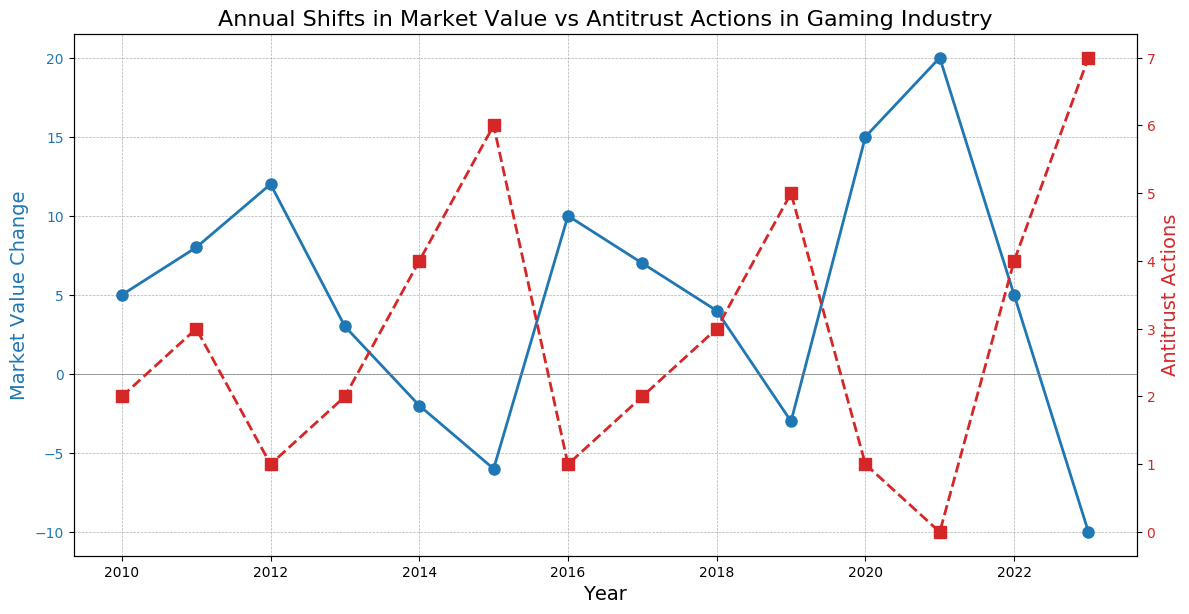How many years had a negative shift in market value? From the figure, identify the years where the line for market value change falls below the zero horizontal line. There are 4 data points where the market value change is negative.
Answer: 4 In which year did the market value change peak? Look for the highest point on the blue line representing the market value change. The peak value is 20 in the year 2021.
Answer: 2021 Which year had the highest number of antitrust actions and what was the market value change in that year? Find the peak of the red line which shows the number of antitrust actions. In 2023, there were 7 antitrust actions and the market value change was -10.
Answer: 2023, -10 What was the average market value change from 2010 to 2013? Sum the market value changes from 2010, 2011, 2012, and 2013, then divide by 4. (5 + 8 + 12 + 3) / 4 = 7
Answer: 7 Compare the market value changes in 2015 and 2016. Which was greater? Compare the data points on the blue line for 2015 and 2016. In 2015, the market value change was -6, and in 2016 it was 10.
Answer: 2016 In which year did the market value change transition from negative to positive, and how many antitrust actions were there in that year? Identify the year where the blue line crosses the zero line upwards. This happens from 2015 to 2016. In 2016, the number of antitrust actions was 1.
Answer: 2016, 1 What can be inferred about the trend in antitrust actions from 2020 to 2023? Observe the red line behavior between 2020 and 2023. The number of antitrust actions increased from 1 in 2020 to 7 in 2023, showing an upward trend.
Answer: Increasing trend Calculate the total market value change between 2018 and 2020. Add the market value changes from 2018, 2019, and 2020: (4 - 3 + 15) = 16
Answer: 16 What was the combined total of the antitrust actions in the years with negative market value changes? Add the antitrust actions for the years when market value change is negative: 2014 (4), 2015 (6), 2019 (5), and 2023 (7). 4 + 6 + 5 + 7 = 22
Answer: 22 